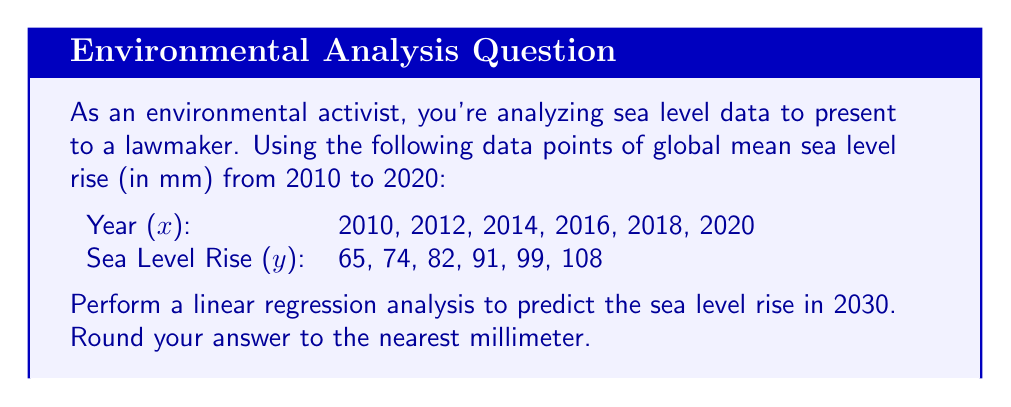Solve this math problem. 1. Let's start by calculating the means of x and y:
   $\bar{x} = \frac{2010 + 2012 + 2014 + 2016 + 2018 + 2020}{6} = 2015$
   $\bar{y} = \frac{65 + 74 + 82 + 91 + 99 + 108}{6} = 86.5$

2. Calculate the slope (m) using the formula:
   $m = \frac{\sum(x_i - \bar{x})(y_i - \bar{y})}{\sum(x_i - \bar{x})^2}$

3. Create a table to calculate the necessary sums:
   | x    | y   | x - x̄ | y - ȳ | (x - x̄)(y - ȳ) | (x - x̄)² |
   |------|-----|-------|-------|----------------|----------|
   | 2010 | 65  | -5    | -21.5 | 107.5          | 25       |
   | 2012 | 74  | -3    | -12.5 | 37.5           | 9        |
   | 2014 | 82  | -1    | -4.5  | 4.5            | 1        |
   | 2016 | 91  | 1     | 4.5   | 4.5            | 1        |
   | 2018 | 99  | 3     | 12.5  | 37.5           | 9        |
   | 2020 | 108 | 5     | 21.5  | 107.5          | 25       |
   |      |     |       | Sum:  | 299            | 70       |

4. Calculate the slope:
   $m = \frac{299}{70} = 4.2714$

5. Calculate the y-intercept (b) using the formula:
   $b = \bar{y} - m\bar{x}$
   $b = 86.5 - 4.2714 \cdot 2015 = -8520.371$

6. The linear regression equation is:
   $y = 4.2714x - 8520.371$

7. To predict the sea level rise in 2030, substitute x = 2030:
   $y = 4.2714 \cdot 2030 - 8520.371 = 151.569$

8. Rounding to the nearest millimeter:
   $y \approx 152$ mm
Answer: 152 mm 